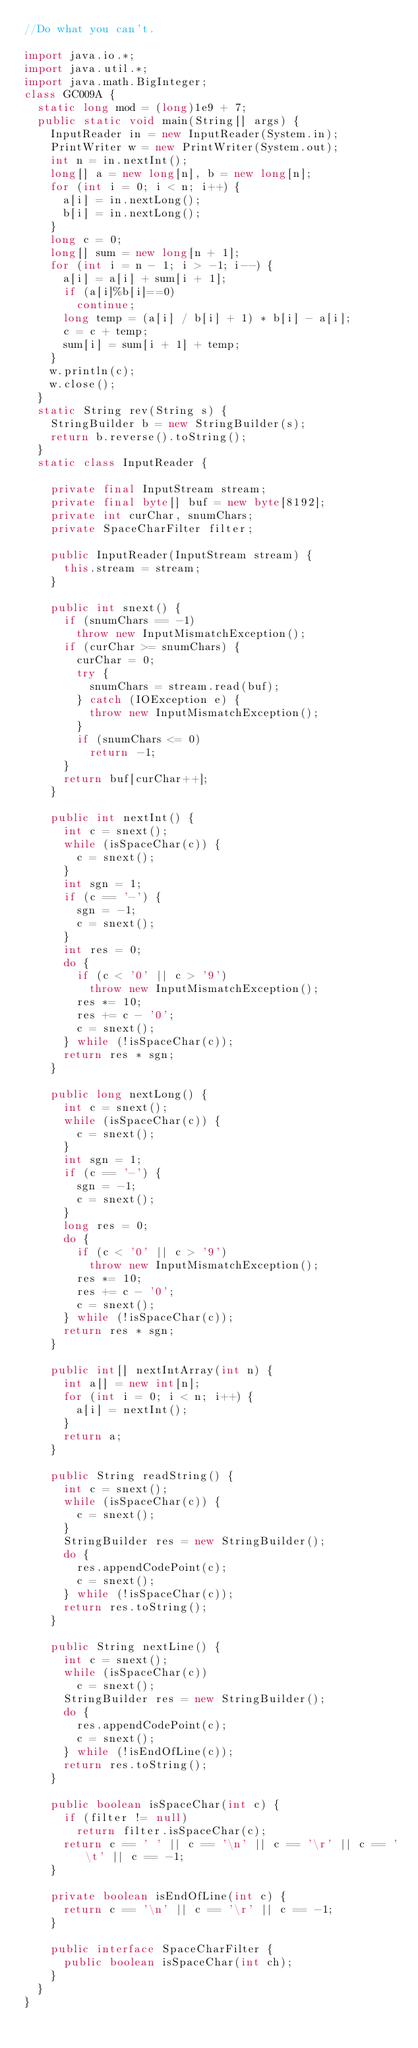<code> <loc_0><loc_0><loc_500><loc_500><_Java_>//Do what you can't.

import java.io.*;
import java.util.*;
import java.math.BigInteger;
class GC009A {
  static long mod = (long)1e9 + 7;
  public static void main(String[] args) {
    InputReader in = new InputReader(System.in);
    PrintWriter w = new PrintWriter(System.out);
    int n = in.nextInt();
    long[] a = new long[n], b = new long[n];
    for (int i = 0; i < n; i++) {
      a[i] = in.nextLong();
      b[i] = in.nextLong();
    }
    long c = 0;
    long[] sum = new long[n + 1];
    for (int i = n - 1; i > -1; i--) {
      a[i] = a[i] + sum[i + 1];
      if (a[i]%b[i]==0)
        continue;
      long temp = (a[i] / b[i] + 1) * b[i] - a[i];
      c = c + temp;
      sum[i] = sum[i + 1] + temp;
    }
    w.println(c);
    w.close();
  }
  static String rev(String s) {
    StringBuilder b = new StringBuilder(s);
    return b.reverse().toString();
  }
  static class InputReader {

    private final InputStream stream;
    private final byte[] buf = new byte[8192];
    private int curChar, snumChars;
    private SpaceCharFilter filter;

    public InputReader(InputStream stream) {
      this.stream = stream;
    }

    public int snext() {
      if (snumChars == -1)
        throw new InputMismatchException();
      if (curChar >= snumChars) {
        curChar = 0;
        try {
          snumChars = stream.read(buf);
        } catch (IOException e) {
          throw new InputMismatchException();
        }
        if (snumChars <= 0)
          return -1;
      }
      return buf[curChar++];
    }

    public int nextInt() {
      int c = snext();
      while (isSpaceChar(c)) {
        c = snext();
      }
      int sgn = 1;
      if (c == '-') {
        sgn = -1;
        c = snext();
      }
      int res = 0;
      do {
        if (c < '0' || c > '9')
          throw new InputMismatchException();
        res *= 10;
        res += c - '0';
        c = snext();
      } while (!isSpaceChar(c));
      return res * sgn;
    }

    public long nextLong() {
      int c = snext();
      while (isSpaceChar(c)) {
        c = snext();
      }
      int sgn = 1;
      if (c == '-') {
        sgn = -1;
        c = snext();
      }
      long res = 0;
      do {
        if (c < '0' || c > '9')
          throw new InputMismatchException();
        res *= 10;
        res += c - '0';
        c = snext();
      } while (!isSpaceChar(c));
      return res * sgn;
    }

    public int[] nextIntArray(int n) {
      int a[] = new int[n];
      for (int i = 0; i < n; i++) {
        a[i] = nextInt();
      }
      return a;
    }

    public String readString() {
      int c = snext();
      while (isSpaceChar(c)) {
        c = snext();
      }
      StringBuilder res = new StringBuilder();
      do {
        res.appendCodePoint(c);
        c = snext();
      } while (!isSpaceChar(c));
      return res.toString();
    }

    public String nextLine() {
      int c = snext();
      while (isSpaceChar(c))
        c = snext();
      StringBuilder res = new StringBuilder();
      do {
        res.appendCodePoint(c);
        c = snext();
      } while (!isEndOfLine(c));
      return res.toString();
    }

    public boolean isSpaceChar(int c) {
      if (filter != null)
        return filter.isSpaceChar(c);
      return c == ' ' || c == '\n' || c == '\r' || c == '\t' || c == -1;
    }

    private boolean isEndOfLine(int c) {
      return c == '\n' || c == '\r' || c == -1;
    }

    public interface SpaceCharFilter {
      public boolean isSpaceChar(int ch);
    }
  }
}
</code> 